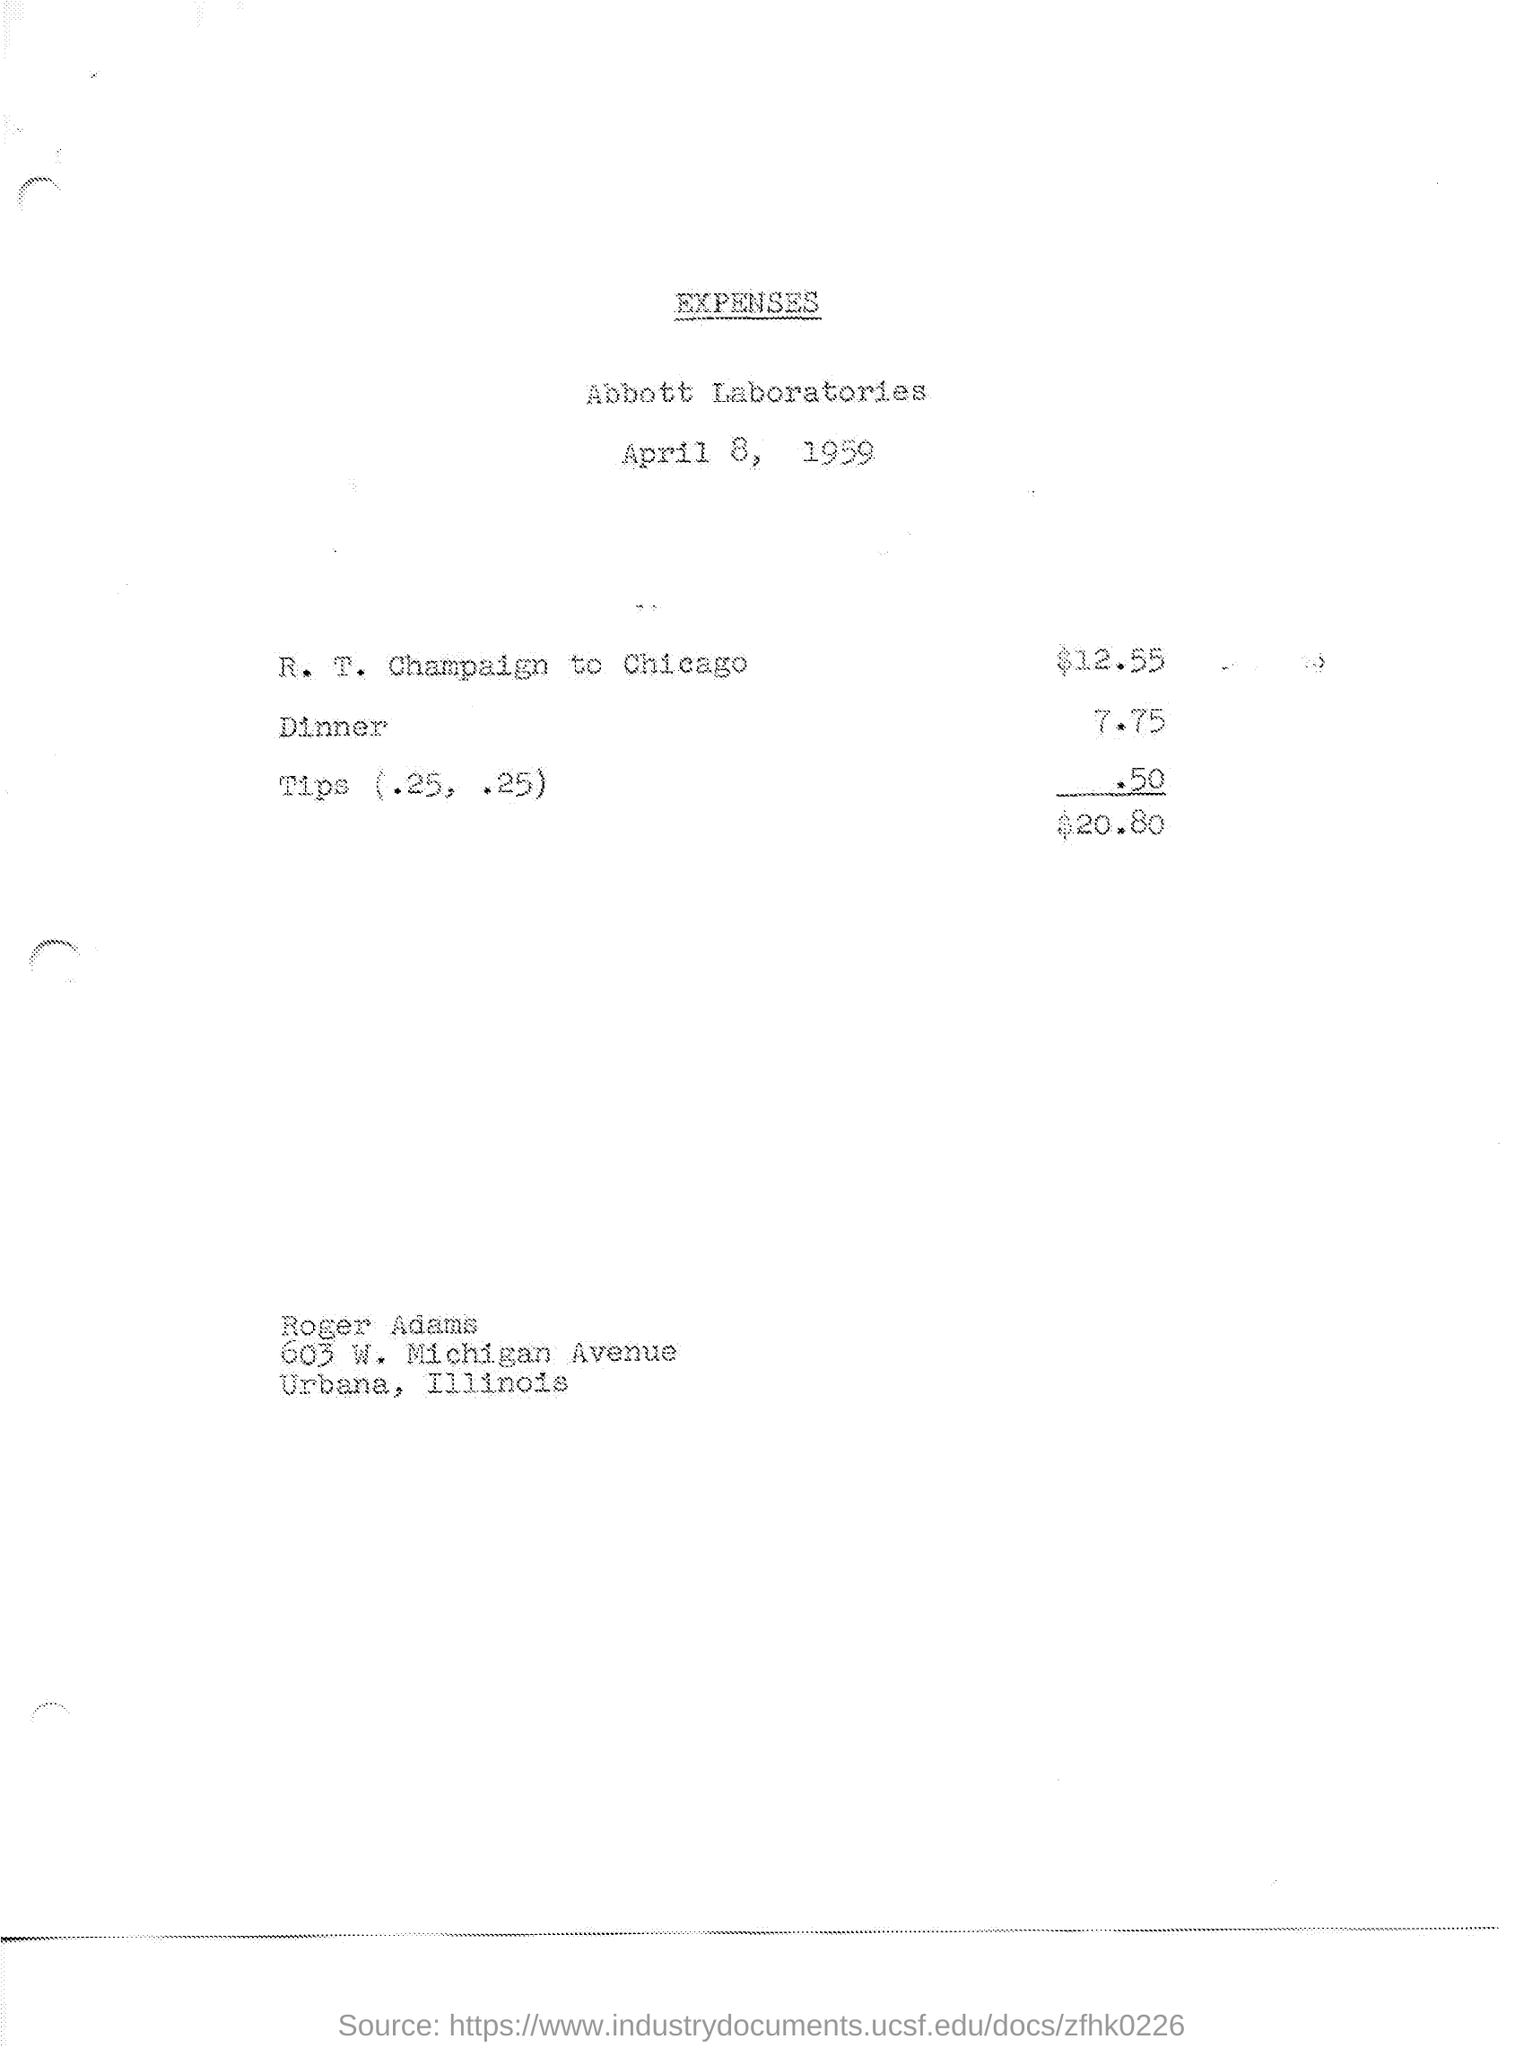What date is shown on this expense sheet? The date on the expense sheet is April 8, 1959. 